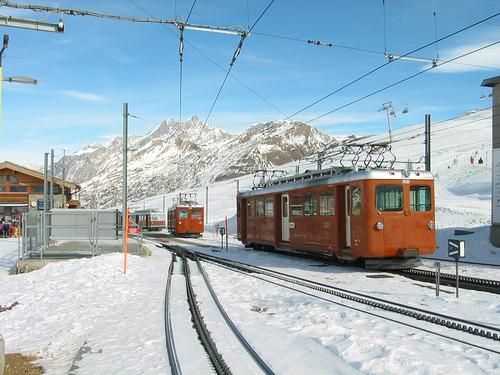What is ropeway called?

Choices:
A) aerial tramway
B) cable way
C) cable car
D) rope way aerial tramway 